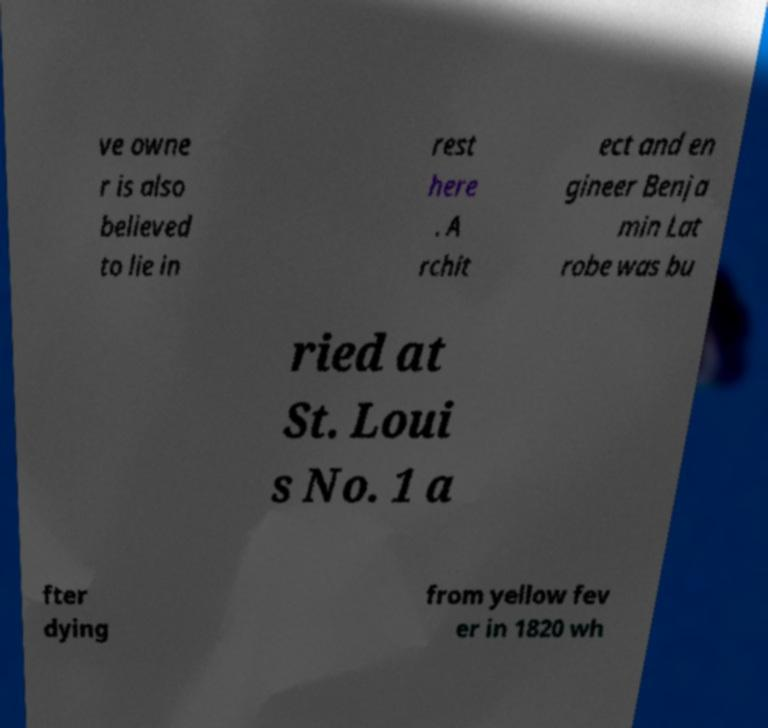Please read and relay the text visible in this image. What does it say? ve owne r is also believed to lie in rest here . A rchit ect and en gineer Benja min Lat robe was bu ried at St. Loui s No. 1 a fter dying from yellow fev er in 1820 wh 